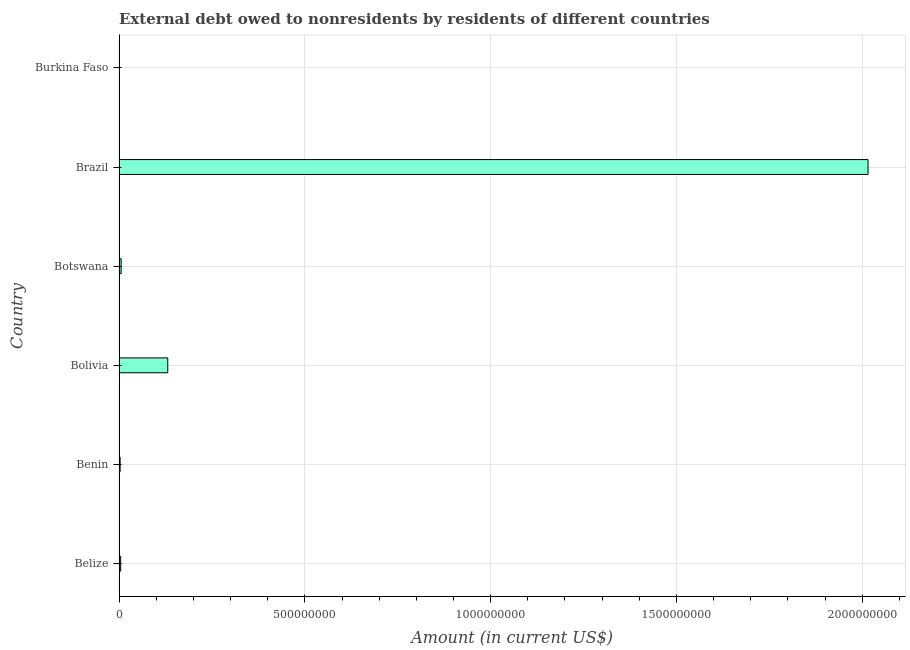Does the graph contain any zero values?
Ensure brevity in your answer.  No. What is the title of the graph?
Offer a terse response. External debt owed to nonresidents by residents of different countries. What is the label or title of the Y-axis?
Provide a short and direct response. Country. What is the debt in Benin?
Offer a terse response. 2.87e+06. Across all countries, what is the maximum debt?
Your answer should be compact. 2.02e+09. Across all countries, what is the minimum debt?
Offer a very short reply. 6.51e+05. In which country was the debt maximum?
Keep it short and to the point. Brazil. In which country was the debt minimum?
Keep it short and to the point. Burkina Faso. What is the sum of the debt?
Offer a terse response. 2.16e+09. What is the difference between the debt in Bolivia and Botswana?
Provide a succinct answer. 1.26e+08. What is the average debt per country?
Provide a succinct answer. 3.60e+08. What is the median debt?
Provide a short and direct response. 4.93e+06. What is the ratio of the debt in Bolivia to that in Burkina Faso?
Offer a terse response. 201.34. What is the difference between the highest and the second highest debt?
Your answer should be compact. 1.88e+09. What is the difference between the highest and the lowest debt?
Ensure brevity in your answer.  2.02e+09. In how many countries, is the debt greater than the average debt taken over all countries?
Your answer should be very brief. 1. Are all the bars in the graph horizontal?
Make the answer very short. Yes. What is the difference between two consecutive major ticks on the X-axis?
Provide a succinct answer. 5.00e+08. Are the values on the major ticks of X-axis written in scientific E-notation?
Your answer should be compact. No. What is the Amount (in current US$) in Belize?
Your answer should be very brief. 4.30e+06. What is the Amount (in current US$) in Benin?
Offer a terse response. 2.87e+06. What is the Amount (in current US$) in Bolivia?
Your answer should be very brief. 1.31e+08. What is the Amount (in current US$) of Botswana?
Offer a terse response. 5.57e+06. What is the Amount (in current US$) in Brazil?
Your response must be concise. 2.02e+09. What is the Amount (in current US$) of Burkina Faso?
Ensure brevity in your answer.  6.51e+05. What is the difference between the Amount (in current US$) in Belize and Benin?
Keep it short and to the point. 1.43e+06. What is the difference between the Amount (in current US$) in Belize and Bolivia?
Your response must be concise. -1.27e+08. What is the difference between the Amount (in current US$) in Belize and Botswana?
Your answer should be compact. -1.27e+06. What is the difference between the Amount (in current US$) in Belize and Brazil?
Provide a succinct answer. -2.01e+09. What is the difference between the Amount (in current US$) in Belize and Burkina Faso?
Give a very brief answer. 3.65e+06. What is the difference between the Amount (in current US$) in Benin and Bolivia?
Keep it short and to the point. -1.28e+08. What is the difference between the Amount (in current US$) in Benin and Botswana?
Your response must be concise. -2.70e+06. What is the difference between the Amount (in current US$) in Benin and Brazil?
Your response must be concise. -2.01e+09. What is the difference between the Amount (in current US$) in Benin and Burkina Faso?
Provide a short and direct response. 2.22e+06. What is the difference between the Amount (in current US$) in Bolivia and Botswana?
Provide a succinct answer. 1.26e+08. What is the difference between the Amount (in current US$) in Bolivia and Brazil?
Your response must be concise. -1.88e+09. What is the difference between the Amount (in current US$) in Bolivia and Burkina Faso?
Ensure brevity in your answer.  1.30e+08. What is the difference between the Amount (in current US$) in Botswana and Brazil?
Provide a succinct answer. -2.01e+09. What is the difference between the Amount (in current US$) in Botswana and Burkina Faso?
Offer a terse response. 4.92e+06. What is the difference between the Amount (in current US$) in Brazil and Burkina Faso?
Keep it short and to the point. 2.02e+09. What is the ratio of the Amount (in current US$) in Belize to that in Benin?
Provide a short and direct response. 1.5. What is the ratio of the Amount (in current US$) in Belize to that in Bolivia?
Provide a short and direct response. 0.03. What is the ratio of the Amount (in current US$) in Belize to that in Botswana?
Offer a very short reply. 0.77. What is the ratio of the Amount (in current US$) in Belize to that in Brazil?
Ensure brevity in your answer.  0. What is the ratio of the Amount (in current US$) in Belize to that in Burkina Faso?
Your response must be concise. 6.61. What is the ratio of the Amount (in current US$) in Benin to that in Bolivia?
Provide a succinct answer. 0.02. What is the ratio of the Amount (in current US$) in Benin to that in Botswana?
Your answer should be compact. 0.52. What is the ratio of the Amount (in current US$) in Benin to that in Brazil?
Provide a succinct answer. 0. What is the ratio of the Amount (in current US$) in Benin to that in Burkina Faso?
Give a very brief answer. 4.4. What is the ratio of the Amount (in current US$) in Bolivia to that in Botswana?
Your answer should be compact. 23.55. What is the ratio of the Amount (in current US$) in Bolivia to that in Brazil?
Your response must be concise. 0.07. What is the ratio of the Amount (in current US$) in Bolivia to that in Burkina Faso?
Offer a very short reply. 201.34. What is the ratio of the Amount (in current US$) in Botswana to that in Brazil?
Offer a very short reply. 0. What is the ratio of the Amount (in current US$) in Botswana to that in Burkina Faso?
Keep it short and to the point. 8.55. What is the ratio of the Amount (in current US$) in Brazil to that in Burkina Faso?
Provide a succinct answer. 3096.3. 